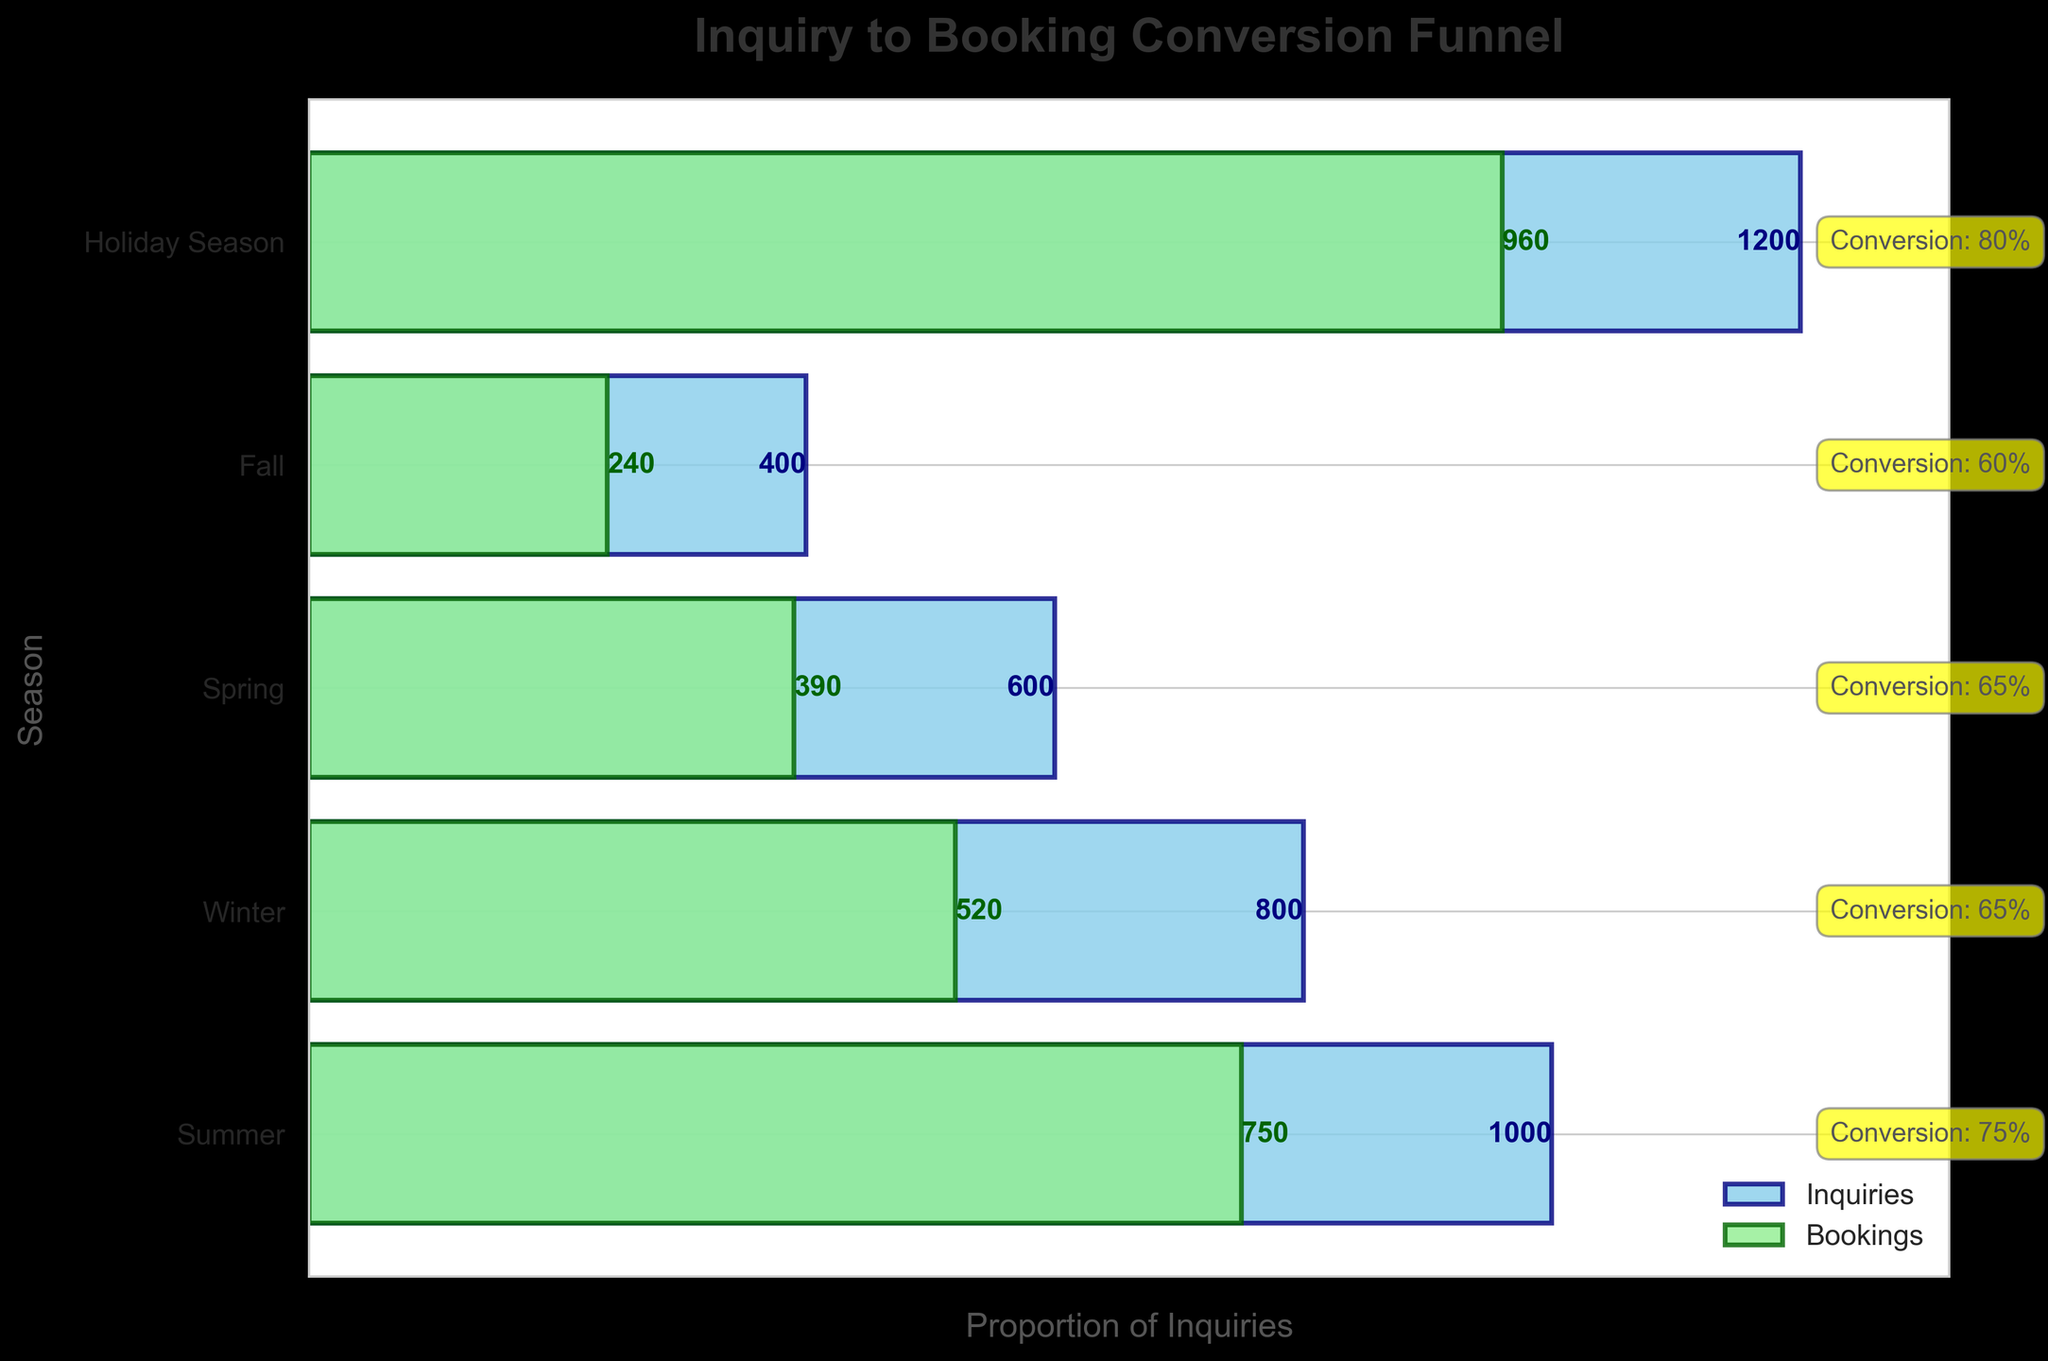Which season has the highest conversion rate? Observing the labels on the right side of the chart, the "Holiday Season" has the highest conversion rate of 80%.
Answer: Holiday Season What is the title of the figure? The title is displayed prominently at the top of the figure. It reads "Inquiry to Booking Conversion Funnel".
Answer: Inquiry to Booking Conversion Funnel How many inquiries were made in the Fall season? By looking at the width of the sky-blue bar for the Fall season and its corresponding text label, there were 400 inquiries made in the Fall.
Answer: 400 Compare the conversion rates of Summer and Spring. Which one is higher? The chart shows the conversion rates for each season. Summer has a 75% conversion rate, while Spring has a 65% conversion rate. Hence, Summer's conversion rate is higher.
Answer: Summer How many bookings were achieved in the Winter season, and what was the conversion rate? By examining the green bar for the Winter season and the text label, we see there were 520 bookings with a conversion rate of 65%.
Answer: 520 bookings, 65% Calculate the total number of inquiries across all seasons. Sum the inquiries for each season: 1000 (Summer) + 800 (Winter) + 600 (Spring) + 400 (Fall) + 1200 (Holiday Season) = 4000.
Answer: 4000 Which season has the lowest conversion rate and what is it? By looking at the conversion rate annotations, the Fall season has the lowest conversion rate at 60%.
Answer: Fall, 60% What is the difference in the number of bookings between the Summer and Spring seasons? Subtract the number of bookings in Spring (390) from the number of bookings in Summer (750): 750 - 390 = 360.
Answer: 360 Is the number of bookings higher in the Winter or Spring season? Compare the number of bookings for each season: Winter has 520 bookings and Spring has 390 bookings, so Winter has more bookings.
Answer: Winter 